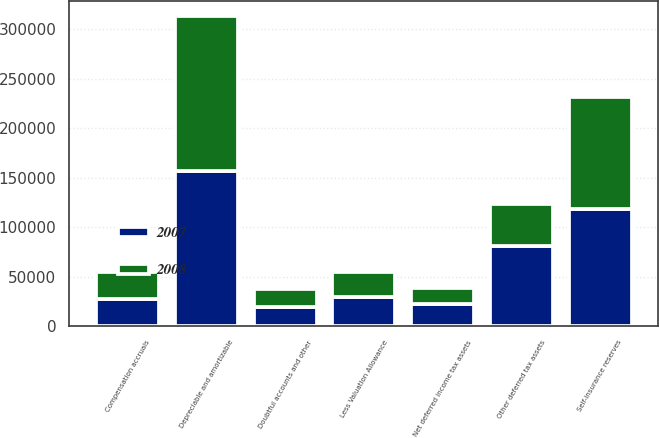Convert chart. <chart><loc_0><loc_0><loc_500><loc_500><stacked_bar_chart><ecel><fcel>Self-insurance reserves<fcel>Compensation accruals<fcel>Other deferred tax assets<fcel>Less Valuation Allowance<fcel>Net deferred income tax assets<fcel>Doubtful accounts and other<fcel>Depreciable and amortizable<nl><fcel>2007<fcel>118836<fcel>27279<fcel>81308<fcel>29788<fcel>22083<fcel>18875<fcel>156677<nl><fcel>2008<fcel>112412<fcel>27848<fcel>42546<fcel>24979<fcel>16869<fcel>18162<fcel>156534<nl></chart> 